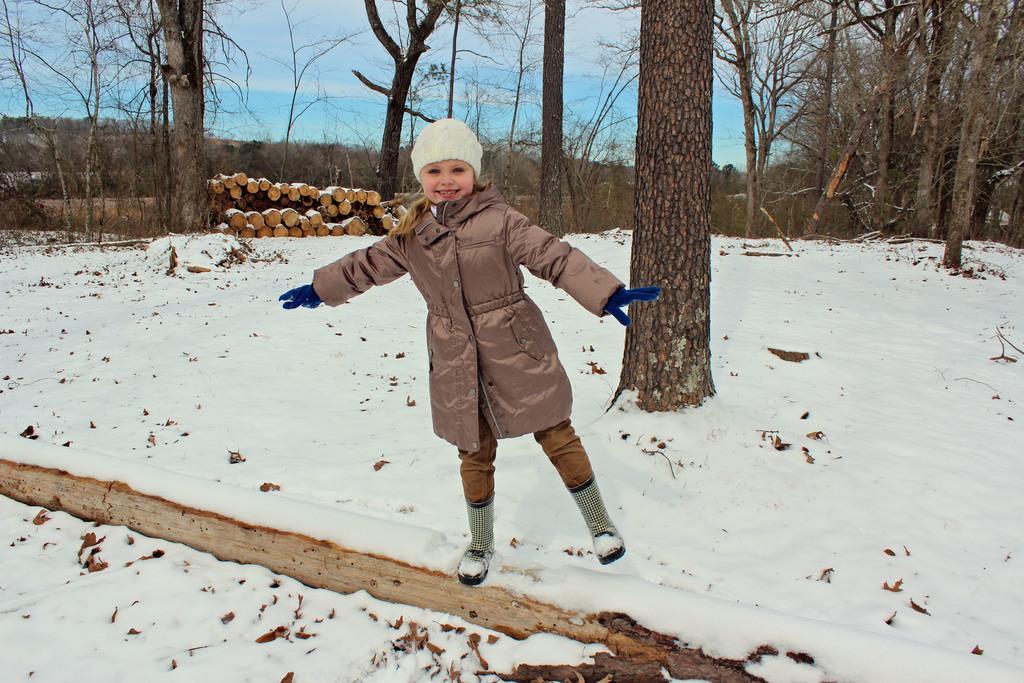In one or two sentences, can you explain what this image depicts? In this image we can see a child standing on the snow. In the background there are sky with clouds, trees, logs and snow on the ground. 